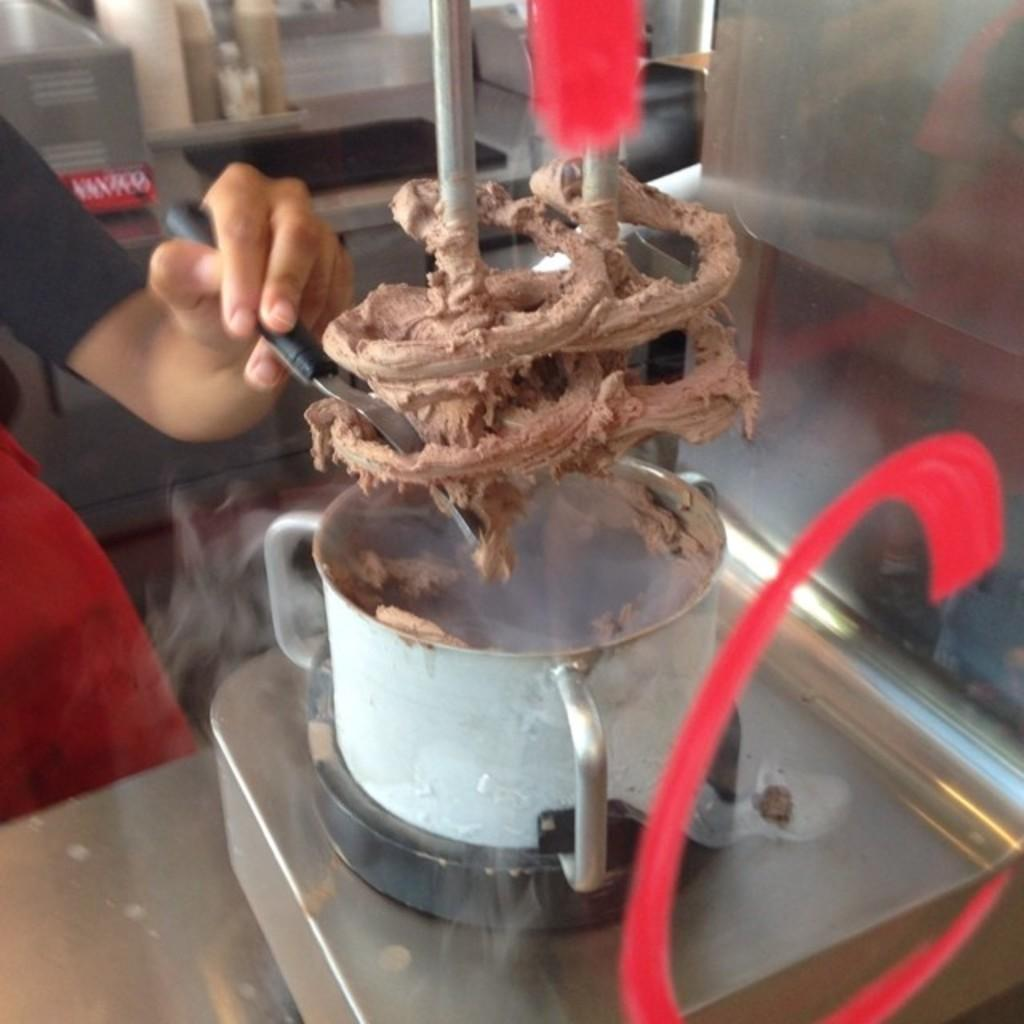What is the main subject in the image? There is a machine in the image. Is there anyone else present in the image besides the machine? Yes, there is a person in the image. What is the person holding in the image? The person is holding an object. What can be seen behind the person in the image? There are multiple objects visible behind the person. What type of current is flowing through the machine in the image? There is no information about any current flowing through the machine in the image. 